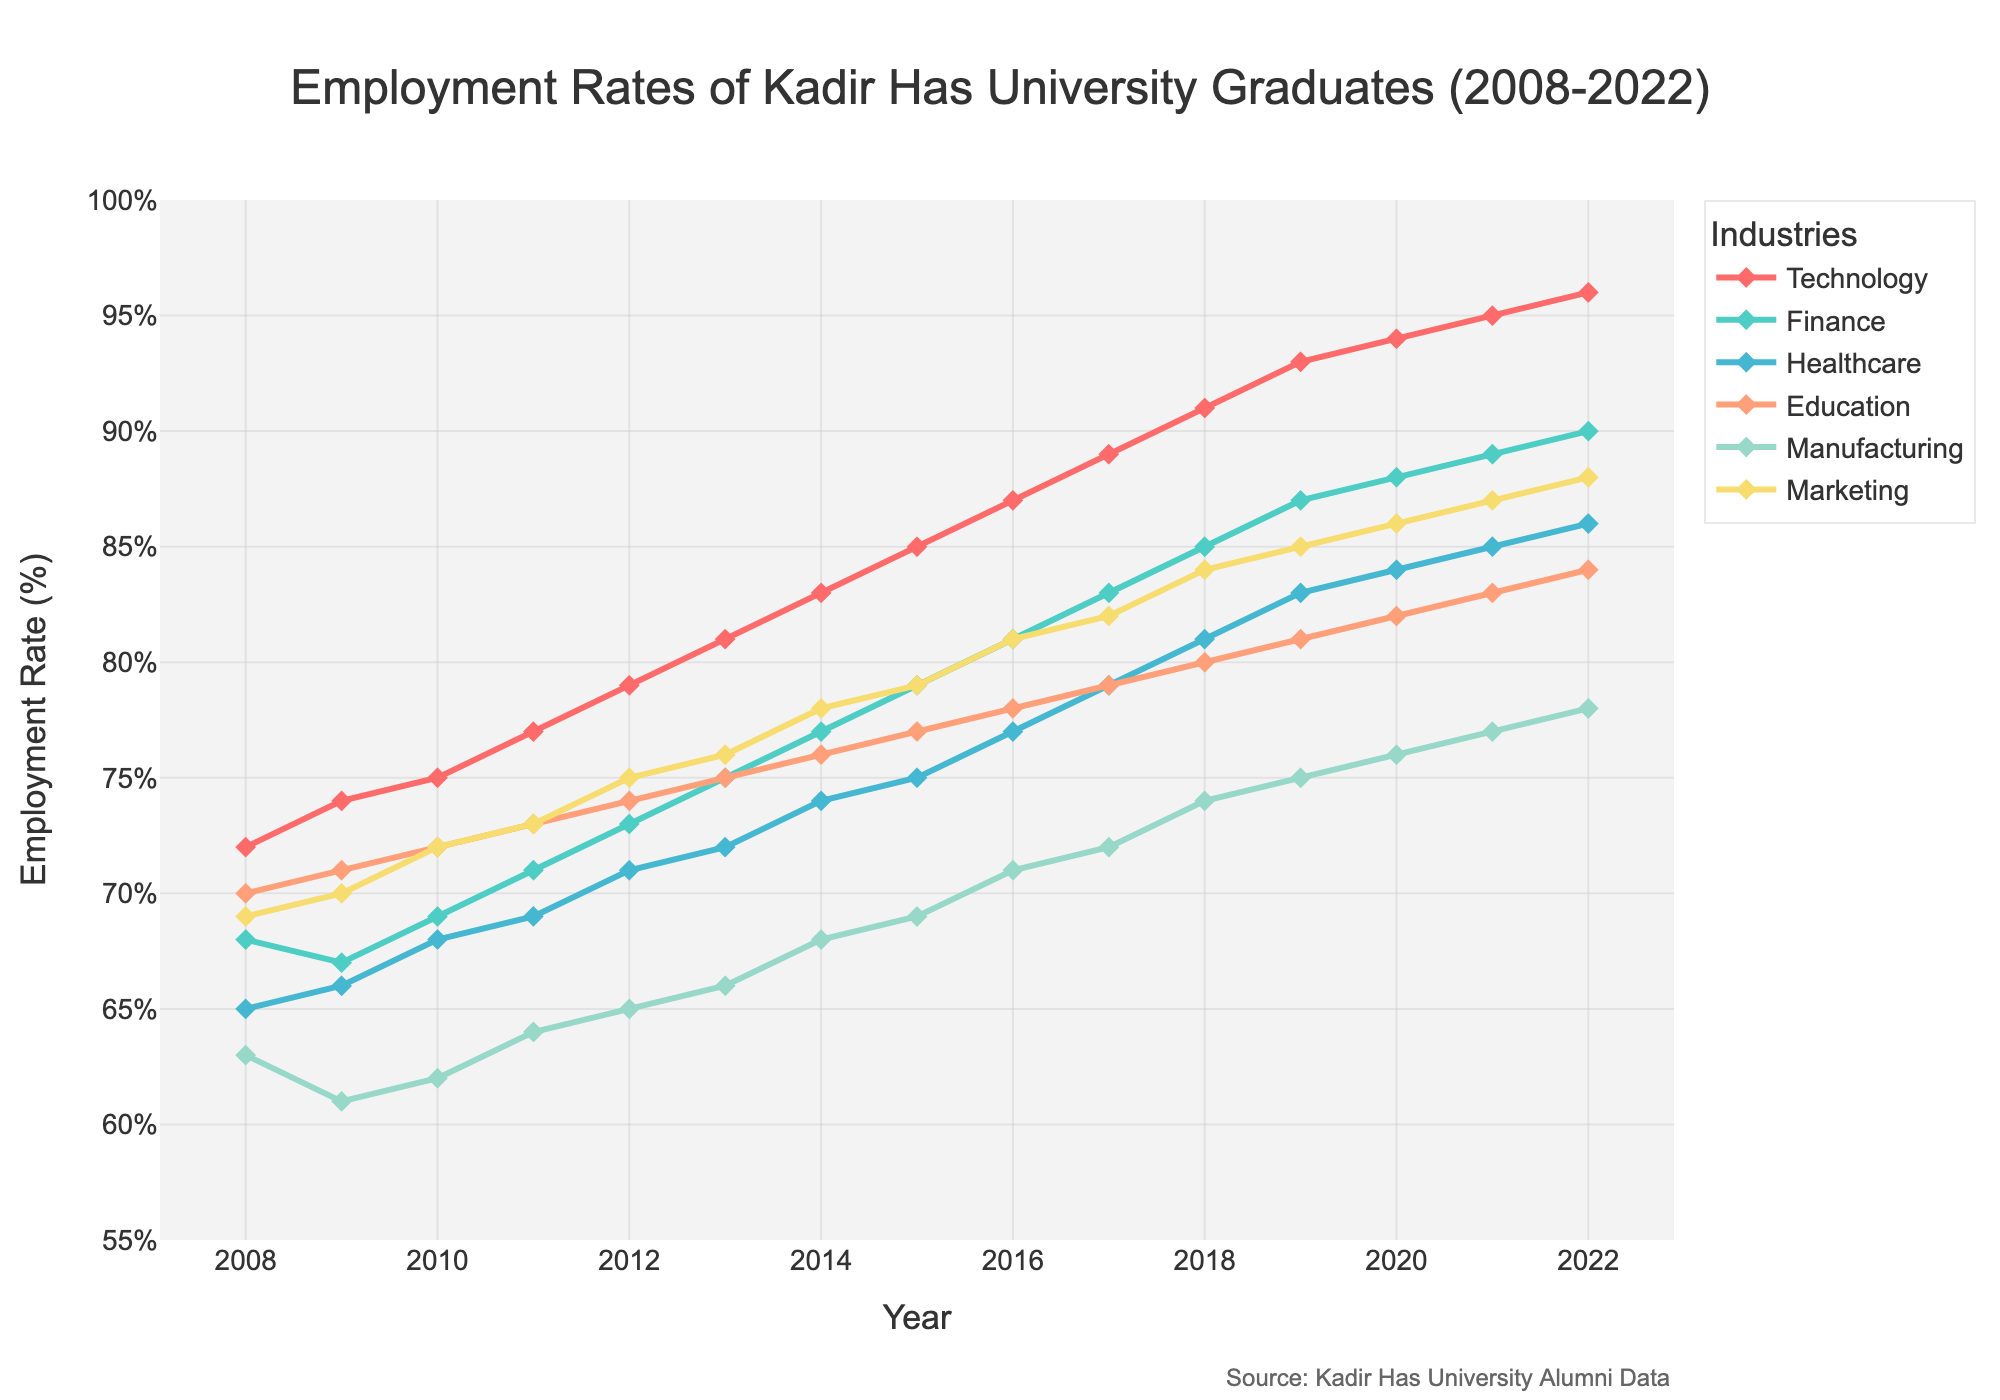What's the trend in employment rates for Technology graduates over the 15 years? The trend for Technology graduates is increasing from 72% in 2008 to 96% in 2022. Identify the line representing Technology and observe how it consistently rises each year over the period.
Answer: Increasing Which industry has the highest employment rate in 2022? Check the employment rates at the end of the graph where the year is 2022 for all industries. The Technology sector shows the highest employment rate at 96%.
Answer: Technology Compare the employment rates of Technology and Healthcare graduates in 2015. Which one is higher and by how much? Look at the employment rates for Technology (85%) and Healthcare (75%) in the year 2015. Subtract Healthcare's rate from Technology's rate: 85% - 75% = 10%.
Answer: Technology by 10% What is the average employment rate of Marketing graduates over the period 2008-2022? Sum up all the employment rates for Marketing from 2008 to 2022 and divide by the number of years (15). (69+70+72+73+75+76+78+79+81+82+84+85+86+87+88) / 15 = 78%
Answer: 78% In which year did the Finance industry see the highest increase in employment rates? Identify the year-to-year changes in the Finance line. The biggest jump is between 2012 (73%) and 2013 (75%), an increase of 2%.
Answer: 2013 Between which two consecutive years did the Manufacturing industry experience its largest decline in employment rates? Check the year-to-year differences in the Manufacturing line. The largest decline is between 2008 (63%) and 2009 (61%), a drop of 2%.
Answer: 2008-2009 Looking at the visual attributes, which industry is represented by the line colored blue and shows a steady increase in employment rates? Observe the colors used for the lines and identify the blue line, noting its employment rate progression. The Healthcare industry's line is blue and steadily increases.
Answer: Healthcare Among all industries, which one had the least variation in employment rates over the 15 years? Calculate the range of employment rates for each industry by subtracting the minimum from the maximum values and identify the one with the smallest range. The Education sector has the smallest range: 84% - 70% = 14%.
Answer: Education 